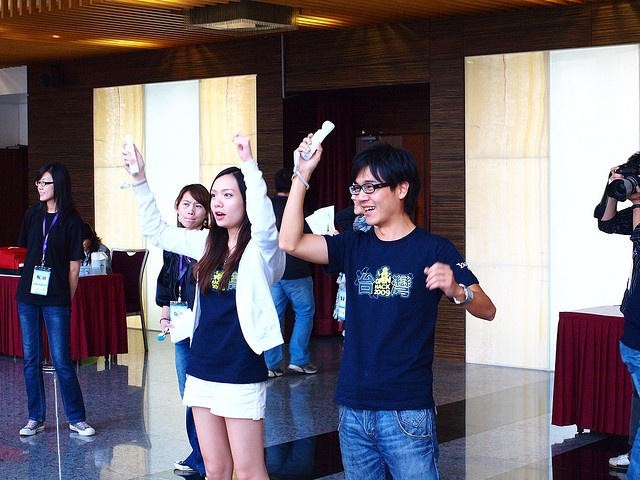Describe the objects in this image and their specific colors. I can see people in tan, navy, black, blue, and lightgray tones, people in tan, white, navy, black, and lightpink tones, people in tan, black, navy, blue, and white tones, people in tan, white, black, navy, and darkblue tones, and people in tan, black, blue, and navy tones in this image. 